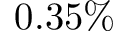Convert formula to latex. <formula><loc_0><loc_0><loc_500><loc_500>0 . 3 5 \%</formula> 